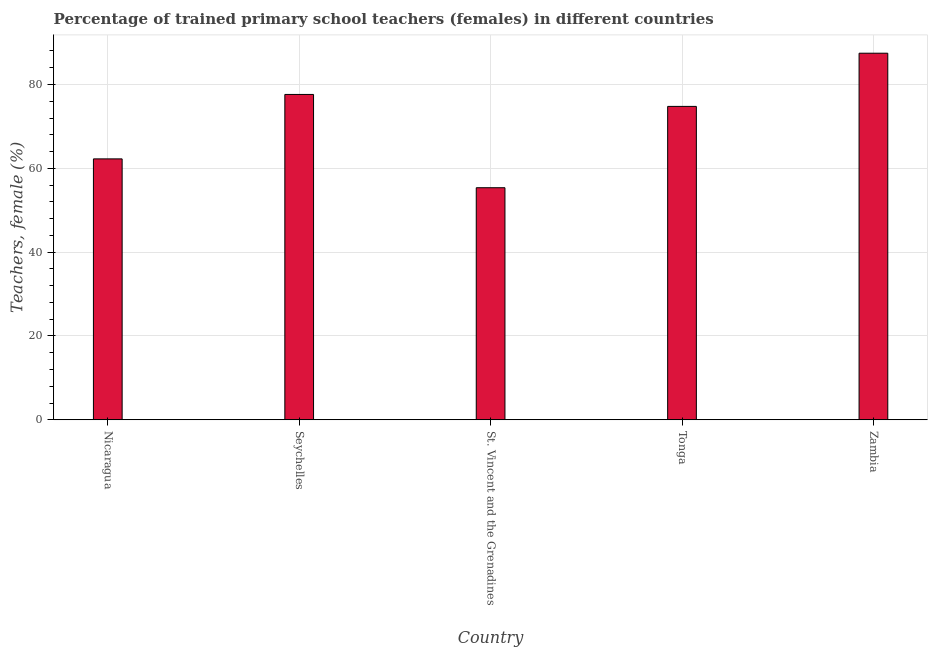Does the graph contain any zero values?
Your answer should be compact. No. What is the title of the graph?
Provide a short and direct response. Percentage of trained primary school teachers (females) in different countries. What is the label or title of the Y-axis?
Provide a short and direct response. Teachers, female (%). What is the percentage of trained female teachers in Zambia?
Make the answer very short. 87.47. Across all countries, what is the maximum percentage of trained female teachers?
Your answer should be very brief. 87.47. Across all countries, what is the minimum percentage of trained female teachers?
Offer a very short reply. 55.37. In which country was the percentage of trained female teachers maximum?
Provide a succinct answer. Zambia. In which country was the percentage of trained female teachers minimum?
Your response must be concise. St. Vincent and the Grenadines. What is the sum of the percentage of trained female teachers?
Ensure brevity in your answer.  357.51. What is the difference between the percentage of trained female teachers in Tonga and Zambia?
Your answer should be very brief. -12.69. What is the average percentage of trained female teachers per country?
Offer a terse response. 71.5. What is the median percentage of trained female teachers?
Your answer should be compact. 74.78. In how many countries, is the percentage of trained female teachers greater than 12 %?
Provide a short and direct response. 5. What is the ratio of the percentage of trained female teachers in Nicaragua to that in Seychelles?
Give a very brief answer. 0.8. Is the difference between the percentage of trained female teachers in Seychelles and Zambia greater than the difference between any two countries?
Provide a succinct answer. No. What is the difference between the highest and the second highest percentage of trained female teachers?
Offer a terse response. 9.84. Is the sum of the percentage of trained female teachers in Seychelles and Tonga greater than the maximum percentage of trained female teachers across all countries?
Your answer should be very brief. Yes. What is the difference between the highest and the lowest percentage of trained female teachers?
Ensure brevity in your answer.  32.1. How many bars are there?
Your answer should be compact. 5. Are the values on the major ticks of Y-axis written in scientific E-notation?
Make the answer very short. No. What is the Teachers, female (%) of Nicaragua?
Provide a succinct answer. 62.26. What is the Teachers, female (%) in Seychelles?
Make the answer very short. 77.63. What is the Teachers, female (%) in St. Vincent and the Grenadines?
Offer a terse response. 55.37. What is the Teachers, female (%) of Tonga?
Offer a terse response. 74.78. What is the Teachers, female (%) of Zambia?
Provide a succinct answer. 87.47. What is the difference between the Teachers, female (%) in Nicaragua and Seychelles?
Your answer should be very brief. -15.37. What is the difference between the Teachers, female (%) in Nicaragua and St. Vincent and the Grenadines?
Offer a terse response. 6.88. What is the difference between the Teachers, female (%) in Nicaragua and Tonga?
Keep it short and to the point. -12.52. What is the difference between the Teachers, female (%) in Nicaragua and Zambia?
Your answer should be very brief. -25.22. What is the difference between the Teachers, female (%) in Seychelles and St. Vincent and the Grenadines?
Provide a succinct answer. 22.26. What is the difference between the Teachers, female (%) in Seychelles and Tonga?
Your answer should be very brief. 2.85. What is the difference between the Teachers, female (%) in Seychelles and Zambia?
Your answer should be compact. -9.84. What is the difference between the Teachers, female (%) in St. Vincent and the Grenadines and Tonga?
Your answer should be compact. -19.4. What is the difference between the Teachers, female (%) in St. Vincent and the Grenadines and Zambia?
Your answer should be compact. -32.1. What is the difference between the Teachers, female (%) in Tonga and Zambia?
Provide a succinct answer. -12.69. What is the ratio of the Teachers, female (%) in Nicaragua to that in Seychelles?
Offer a very short reply. 0.8. What is the ratio of the Teachers, female (%) in Nicaragua to that in St. Vincent and the Grenadines?
Ensure brevity in your answer.  1.12. What is the ratio of the Teachers, female (%) in Nicaragua to that in Tonga?
Provide a short and direct response. 0.83. What is the ratio of the Teachers, female (%) in Nicaragua to that in Zambia?
Offer a terse response. 0.71. What is the ratio of the Teachers, female (%) in Seychelles to that in St. Vincent and the Grenadines?
Provide a succinct answer. 1.4. What is the ratio of the Teachers, female (%) in Seychelles to that in Tonga?
Make the answer very short. 1.04. What is the ratio of the Teachers, female (%) in Seychelles to that in Zambia?
Provide a succinct answer. 0.89. What is the ratio of the Teachers, female (%) in St. Vincent and the Grenadines to that in Tonga?
Provide a succinct answer. 0.74. What is the ratio of the Teachers, female (%) in St. Vincent and the Grenadines to that in Zambia?
Provide a succinct answer. 0.63. What is the ratio of the Teachers, female (%) in Tonga to that in Zambia?
Your answer should be very brief. 0.85. 